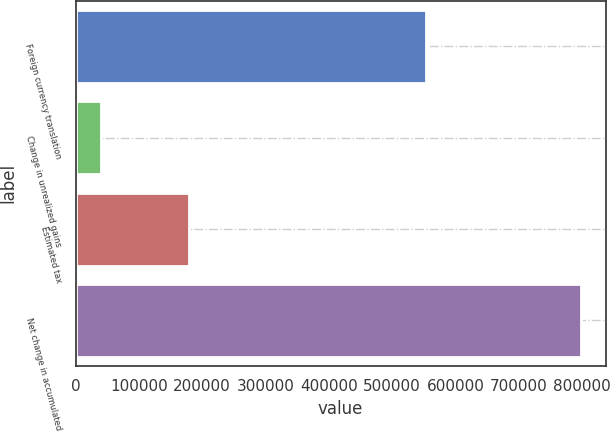Convert chart. <chart><loc_0><loc_0><loc_500><loc_500><bar_chart><fcel>Foreign currency translation<fcel>Change in unrealized gains<fcel>Estimated tax<fcel>Net change in accumulated<nl><fcel>553490<fcel>40522<fcel>179348<fcel>797791<nl></chart> 